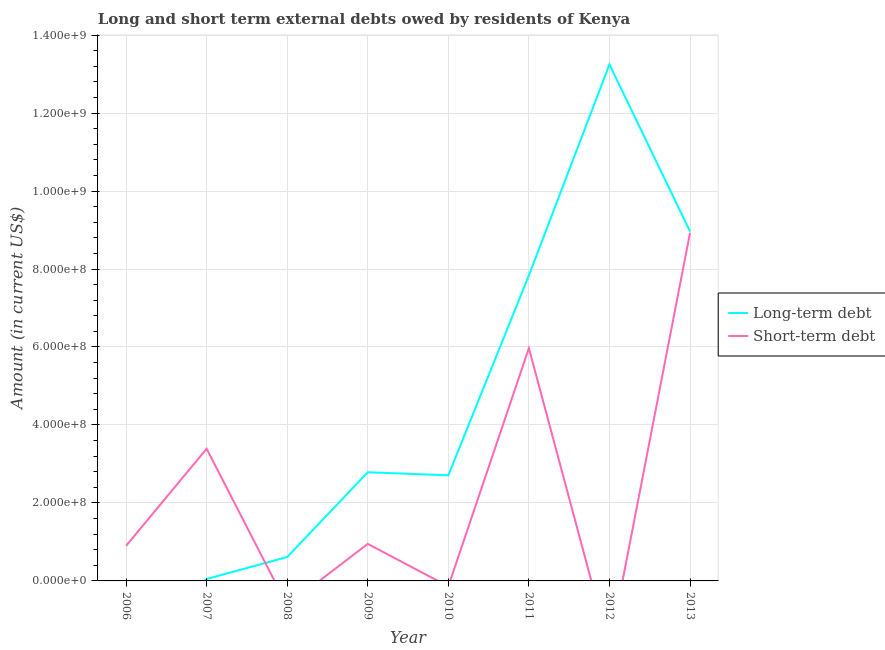How many different coloured lines are there?
Make the answer very short. 2. Does the line corresponding to short-term debts owed by residents intersect with the line corresponding to long-term debts owed by residents?
Give a very brief answer. Yes. What is the long-term debts owed by residents in 2008?
Offer a terse response. 6.13e+07. Across all years, what is the maximum short-term debts owed by residents?
Ensure brevity in your answer.  8.93e+08. What is the total short-term debts owed by residents in the graph?
Make the answer very short. 2.01e+09. What is the difference between the short-term debts owed by residents in 2006 and that in 2007?
Offer a very short reply. -2.49e+08. What is the difference between the short-term debts owed by residents in 2009 and the long-term debts owed by residents in 2008?
Ensure brevity in your answer.  3.37e+07. What is the average long-term debts owed by residents per year?
Your answer should be compact. 4.53e+08. In the year 2011, what is the difference between the long-term debts owed by residents and short-term debts owed by residents?
Your response must be concise. 1.87e+08. In how many years, is the short-term debts owed by residents greater than 600000000 US$?
Your answer should be very brief. 1. What is the ratio of the short-term debts owed by residents in 2006 to that in 2009?
Ensure brevity in your answer.  0.95. Is the long-term debts owed by residents in 2007 less than that in 2010?
Your answer should be compact. Yes. What is the difference between the highest and the second highest short-term debts owed by residents?
Provide a succinct answer. 2.96e+08. What is the difference between the highest and the lowest short-term debts owed by residents?
Keep it short and to the point. 8.93e+08. In how many years, is the short-term debts owed by residents greater than the average short-term debts owed by residents taken over all years?
Your response must be concise. 3. Is the sum of the short-term debts owed by residents in 2007 and 2011 greater than the maximum long-term debts owed by residents across all years?
Offer a very short reply. No. Does the short-term debts owed by residents monotonically increase over the years?
Your answer should be very brief. No. Are the values on the major ticks of Y-axis written in scientific E-notation?
Keep it short and to the point. Yes. How many legend labels are there?
Provide a short and direct response. 2. How are the legend labels stacked?
Make the answer very short. Vertical. What is the title of the graph?
Give a very brief answer. Long and short term external debts owed by residents of Kenya. Does "IMF concessional" appear as one of the legend labels in the graph?
Offer a terse response. No. What is the label or title of the X-axis?
Offer a terse response. Year. What is the Amount (in current US$) of Short-term debt in 2006?
Make the answer very short. 9.00e+07. What is the Amount (in current US$) of Long-term debt in 2007?
Provide a succinct answer. 4.97e+06. What is the Amount (in current US$) in Short-term debt in 2007?
Keep it short and to the point. 3.39e+08. What is the Amount (in current US$) in Long-term debt in 2008?
Provide a succinct answer. 6.13e+07. What is the Amount (in current US$) in Short-term debt in 2008?
Your answer should be compact. 0. What is the Amount (in current US$) of Long-term debt in 2009?
Keep it short and to the point. 2.79e+08. What is the Amount (in current US$) in Short-term debt in 2009?
Provide a short and direct response. 9.50e+07. What is the Amount (in current US$) of Long-term debt in 2010?
Ensure brevity in your answer.  2.71e+08. What is the Amount (in current US$) of Long-term debt in 2011?
Offer a very short reply. 7.84e+08. What is the Amount (in current US$) of Short-term debt in 2011?
Keep it short and to the point. 5.97e+08. What is the Amount (in current US$) of Long-term debt in 2012?
Make the answer very short. 1.32e+09. What is the Amount (in current US$) in Short-term debt in 2012?
Offer a very short reply. 0. What is the Amount (in current US$) in Long-term debt in 2013?
Keep it short and to the point. 8.96e+08. What is the Amount (in current US$) of Short-term debt in 2013?
Give a very brief answer. 8.93e+08. Across all years, what is the maximum Amount (in current US$) in Long-term debt?
Offer a terse response. 1.32e+09. Across all years, what is the maximum Amount (in current US$) of Short-term debt?
Keep it short and to the point. 8.93e+08. Across all years, what is the minimum Amount (in current US$) of Short-term debt?
Provide a succinct answer. 0. What is the total Amount (in current US$) in Long-term debt in the graph?
Your answer should be very brief. 3.62e+09. What is the total Amount (in current US$) of Short-term debt in the graph?
Offer a terse response. 2.01e+09. What is the difference between the Amount (in current US$) in Short-term debt in 2006 and that in 2007?
Offer a terse response. -2.49e+08. What is the difference between the Amount (in current US$) in Short-term debt in 2006 and that in 2009?
Ensure brevity in your answer.  -5.00e+06. What is the difference between the Amount (in current US$) of Short-term debt in 2006 and that in 2011?
Make the answer very short. -5.07e+08. What is the difference between the Amount (in current US$) of Short-term debt in 2006 and that in 2013?
Ensure brevity in your answer.  -8.03e+08. What is the difference between the Amount (in current US$) of Long-term debt in 2007 and that in 2008?
Make the answer very short. -5.63e+07. What is the difference between the Amount (in current US$) of Long-term debt in 2007 and that in 2009?
Your response must be concise. -2.74e+08. What is the difference between the Amount (in current US$) in Short-term debt in 2007 and that in 2009?
Your response must be concise. 2.44e+08. What is the difference between the Amount (in current US$) in Long-term debt in 2007 and that in 2010?
Offer a terse response. -2.66e+08. What is the difference between the Amount (in current US$) of Long-term debt in 2007 and that in 2011?
Give a very brief answer. -7.79e+08. What is the difference between the Amount (in current US$) in Short-term debt in 2007 and that in 2011?
Provide a succinct answer. -2.58e+08. What is the difference between the Amount (in current US$) in Long-term debt in 2007 and that in 2012?
Make the answer very short. -1.32e+09. What is the difference between the Amount (in current US$) of Long-term debt in 2007 and that in 2013?
Make the answer very short. -8.91e+08. What is the difference between the Amount (in current US$) in Short-term debt in 2007 and that in 2013?
Your answer should be very brief. -5.54e+08. What is the difference between the Amount (in current US$) in Long-term debt in 2008 and that in 2009?
Ensure brevity in your answer.  -2.18e+08. What is the difference between the Amount (in current US$) of Long-term debt in 2008 and that in 2010?
Keep it short and to the point. -2.10e+08. What is the difference between the Amount (in current US$) in Long-term debt in 2008 and that in 2011?
Your response must be concise. -7.22e+08. What is the difference between the Amount (in current US$) of Long-term debt in 2008 and that in 2012?
Offer a very short reply. -1.26e+09. What is the difference between the Amount (in current US$) of Long-term debt in 2008 and that in 2013?
Provide a succinct answer. -8.35e+08. What is the difference between the Amount (in current US$) of Long-term debt in 2009 and that in 2010?
Your response must be concise. 7.98e+06. What is the difference between the Amount (in current US$) in Long-term debt in 2009 and that in 2011?
Give a very brief answer. -5.05e+08. What is the difference between the Amount (in current US$) in Short-term debt in 2009 and that in 2011?
Your answer should be compact. -5.02e+08. What is the difference between the Amount (in current US$) of Long-term debt in 2009 and that in 2012?
Your answer should be compact. -1.05e+09. What is the difference between the Amount (in current US$) in Long-term debt in 2009 and that in 2013?
Ensure brevity in your answer.  -6.18e+08. What is the difference between the Amount (in current US$) of Short-term debt in 2009 and that in 2013?
Offer a terse response. -7.98e+08. What is the difference between the Amount (in current US$) in Long-term debt in 2010 and that in 2011?
Provide a short and direct response. -5.13e+08. What is the difference between the Amount (in current US$) of Long-term debt in 2010 and that in 2012?
Provide a succinct answer. -1.05e+09. What is the difference between the Amount (in current US$) in Long-term debt in 2010 and that in 2013?
Make the answer very short. -6.26e+08. What is the difference between the Amount (in current US$) of Long-term debt in 2011 and that in 2012?
Give a very brief answer. -5.41e+08. What is the difference between the Amount (in current US$) in Long-term debt in 2011 and that in 2013?
Give a very brief answer. -1.13e+08. What is the difference between the Amount (in current US$) in Short-term debt in 2011 and that in 2013?
Provide a succinct answer. -2.96e+08. What is the difference between the Amount (in current US$) of Long-term debt in 2012 and that in 2013?
Offer a terse response. 4.28e+08. What is the difference between the Amount (in current US$) of Long-term debt in 2007 and the Amount (in current US$) of Short-term debt in 2009?
Provide a short and direct response. -9.00e+07. What is the difference between the Amount (in current US$) in Long-term debt in 2007 and the Amount (in current US$) in Short-term debt in 2011?
Your answer should be compact. -5.92e+08. What is the difference between the Amount (in current US$) in Long-term debt in 2007 and the Amount (in current US$) in Short-term debt in 2013?
Your response must be concise. -8.88e+08. What is the difference between the Amount (in current US$) of Long-term debt in 2008 and the Amount (in current US$) of Short-term debt in 2009?
Your answer should be compact. -3.37e+07. What is the difference between the Amount (in current US$) in Long-term debt in 2008 and the Amount (in current US$) in Short-term debt in 2011?
Provide a succinct answer. -5.36e+08. What is the difference between the Amount (in current US$) of Long-term debt in 2008 and the Amount (in current US$) of Short-term debt in 2013?
Offer a very short reply. -8.32e+08. What is the difference between the Amount (in current US$) of Long-term debt in 2009 and the Amount (in current US$) of Short-term debt in 2011?
Offer a terse response. -3.18e+08. What is the difference between the Amount (in current US$) of Long-term debt in 2009 and the Amount (in current US$) of Short-term debt in 2013?
Your response must be concise. -6.14e+08. What is the difference between the Amount (in current US$) in Long-term debt in 2010 and the Amount (in current US$) in Short-term debt in 2011?
Give a very brief answer. -3.26e+08. What is the difference between the Amount (in current US$) of Long-term debt in 2010 and the Amount (in current US$) of Short-term debt in 2013?
Give a very brief answer. -6.22e+08. What is the difference between the Amount (in current US$) of Long-term debt in 2011 and the Amount (in current US$) of Short-term debt in 2013?
Keep it short and to the point. -1.09e+08. What is the difference between the Amount (in current US$) in Long-term debt in 2012 and the Amount (in current US$) in Short-term debt in 2013?
Provide a succinct answer. 4.32e+08. What is the average Amount (in current US$) of Long-term debt per year?
Your answer should be very brief. 4.53e+08. What is the average Amount (in current US$) of Short-term debt per year?
Give a very brief answer. 2.52e+08. In the year 2007, what is the difference between the Amount (in current US$) in Long-term debt and Amount (in current US$) in Short-term debt?
Your answer should be very brief. -3.34e+08. In the year 2009, what is the difference between the Amount (in current US$) in Long-term debt and Amount (in current US$) in Short-term debt?
Your answer should be very brief. 1.84e+08. In the year 2011, what is the difference between the Amount (in current US$) of Long-term debt and Amount (in current US$) of Short-term debt?
Your response must be concise. 1.87e+08. In the year 2013, what is the difference between the Amount (in current US$) in Long-term debt and Amount (in current US$) in Short-term debt?
Give a very brief answer. 3.43e+06. What is the ratio of the Amount (in current US$) of Short-term debt in 2006 to that in 2007?
Keep it short and to the point. 0.27. What is the ratio of the Amount (in current US$) in Short-term debt in 2006 to that in 2009?
Offer a very short reply. 0.95. What is the ratio of the Amount (in current US$) in Short-term debt in 2006 to that in 2011?
Your response must be concise. 0.15. What is the ratio of the Amount (in current US$) of Short-term debt in 2006 to that in 2013?
Offer a terse response. 0.1. What is the ratio of the Amount (in current US$) of Long-term debt in 2007 to that in 2008?
Your response must be concise. 0.08. What is the ratio of the Amount (in current US$) of Long-term debt in 2007 to that in 2009?
Make the answer very short. 0.02. What is the ratio of the Amount (in current US$) of Short-term debt in 2007 to that in 2009?
Your response must be concise. 3.57. What is the ratio of the Amount (in current US$) in Long-term debt in 2007 to that in 2010?
Provide a short and direct response. 0.02. What is the ratio of the Amount (in current US$) in Long-term debt in 2007 to that in 2011?
Your answer should be very brief. 0.01. What is the ratio of the Amount (in current US$) of Short-term debt in 2007 to that in 2011?
Your response must be concise. 0.57. What is the ratio of the Amount (in current US$) in Long-term debt in 2007 to that in 2012?
Ensure brevity in your answer.  0. What is the ratio of the Amount (in current US$) in Long-term debt in 2007 to that in 2013?
Ensure brevity in your answer.  0.01. What is the ratio of the Amount (in current US$) in Short-term debt in 2007 to that in 2013?
Ensure brevity in your answer.  0.38. What is the ratio of the Amount (in current US$) in Long-term debt in 2008 to that in 2009?
Offer a very short reply. 0.22. What is the ratio of the Amount (in current US$) of Long-term debt in 2008 to that in 2010?
Keep it short and to the point. 0.23. What is the ratio of the Amount (in current US$) in Long-term debt in 2008 to that in 2011?
Offer a terse response. 0.08. What is the ratio of the Amount (in current US$) of Long-term debt in 2008 to that in 2012?
Provide a succinct answer. 0.05. What is the ratio of the Amount (in current US$) of Long-term debt in 2008 to that in 2013?
Your response must be concise. 0.07. What is the ratio of the Amount (in current US$) in Long-term debt in 2009 to that in 2010?
Ensure brevity in your answer.  1.03. What is the ratio of the Amount (in current US$) in Long-term debt in 2009 to that in 2011?
Your answer should be very brief. 0.36. What is the ratio of the Amount (in current US$) of Short-term debt in 2009 to that in 2011?
Offer a terse response. 0.16. What is the ratio of the Amount (in current US$) of Long-term debt in 2009 to that in 2012?
Ensure brevity in your answer.  0.21. What is the ratio of the Amount (in current US$) in Long-term debt in 2009 to that in 2013?
Your response must be concise. 0.31. What is the ratio of the Amount (in current US$) of Short-term debt in 2009 to that in 2013?
Your answer should be compact. 0.11. What is the ratio of the Amount (in current US$) of Long-term debt in 2010 to that in 2011?
Provide a short and direct response. 0.35. What is the ratio of the Amount (in current US$) of Long-term debt in 2010 to that in 2012?
Provide a short and direct response. 0.2. What is the ratio of the Amount (in current US$) of Long-term debt in 2010 to that in 2013?
Provide a short and direct response. 0.3. What is the ratio of the Amount (in current US$) in Long-term debt in 2011 to that in 2012?
Your response must be concise. 0.59. What is the ratio of the Amount (in current US$) of Long-term debt in 2011 to that in 2013?
Your answer should be very brief. 0.87. What is the ratio of the Amount (in current US$) in Short-term debt in 2011 to that in 2013?
Provide a succinct answer. 0.67. What is the ratio of the Amount (in current US$) of Long-term debt in 2012 to that in 2013?
Give a very brief answer. 1.48. What is the difference between the highest and the second highest Amount (in current US$) in Long-term debt?
Make the answer very short. 4.28e+08. What is the difference between the highest and the second highest Amount (in current US$) of Short-term debt?
Make the answer very short. 2.96e+08. What is the difference between the highest and the lowest Amount (in current US$) in Long-term debt?
Provide a short and direct response. 1.32e+09. What is the difference between the highest and the lowest Amount (in current US$) in Short-term debt?
Keep it short and to the point. 8.93e+08. 